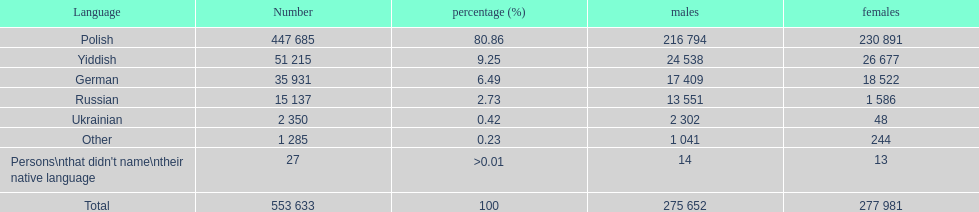Which language did the most people in the imperial census of 1897 speak in the p&#322;ock governorate? Polish. 